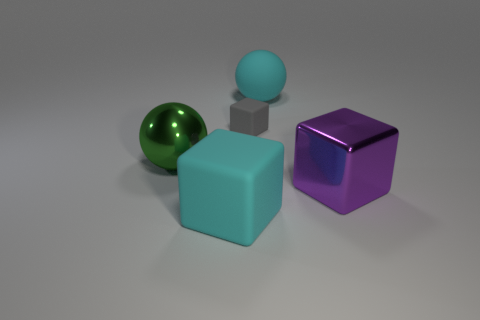There is a ball that is made of the same material as the gray block; what size is it? The ball that shares the same material as the gray block appears to be smaller in size when compared to the surrounding objects. 